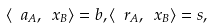Convert formula to latex. <formula><loc_0><loc_0><loc_500><loc_500>\langle \ a _ { A } , \ x _ { B } \rangle = b , \langle \ r _ { A } , \ x _ { B } \rangle = s ,</formula> 